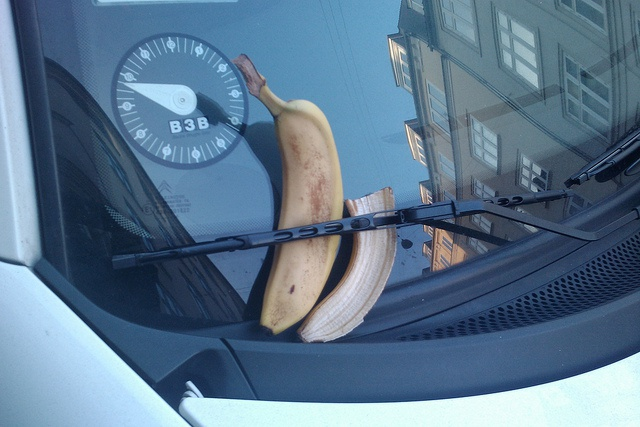Describe the objects in this image and their specific colors. I can see car in blue, gray, and navy tones and banana in lavender, darkgray, tan, and gray tones in this image. 